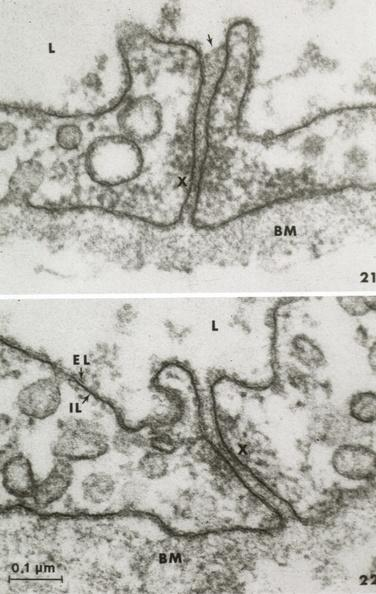what is present?
Answer the question using a single word or phrase. Capillary 